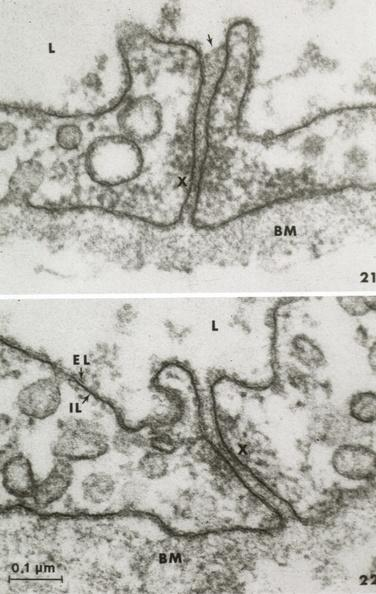what is present?
Answer the question using a single word or phrase. Capillary 